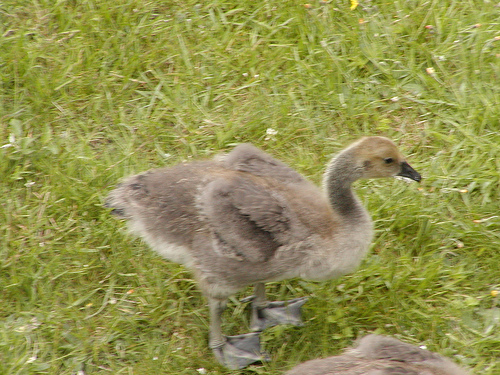<image>
Is the grass on the bird? Yes. Looking at the image, I can see the grass is positioned on top of the bird, with the bird providing support. 